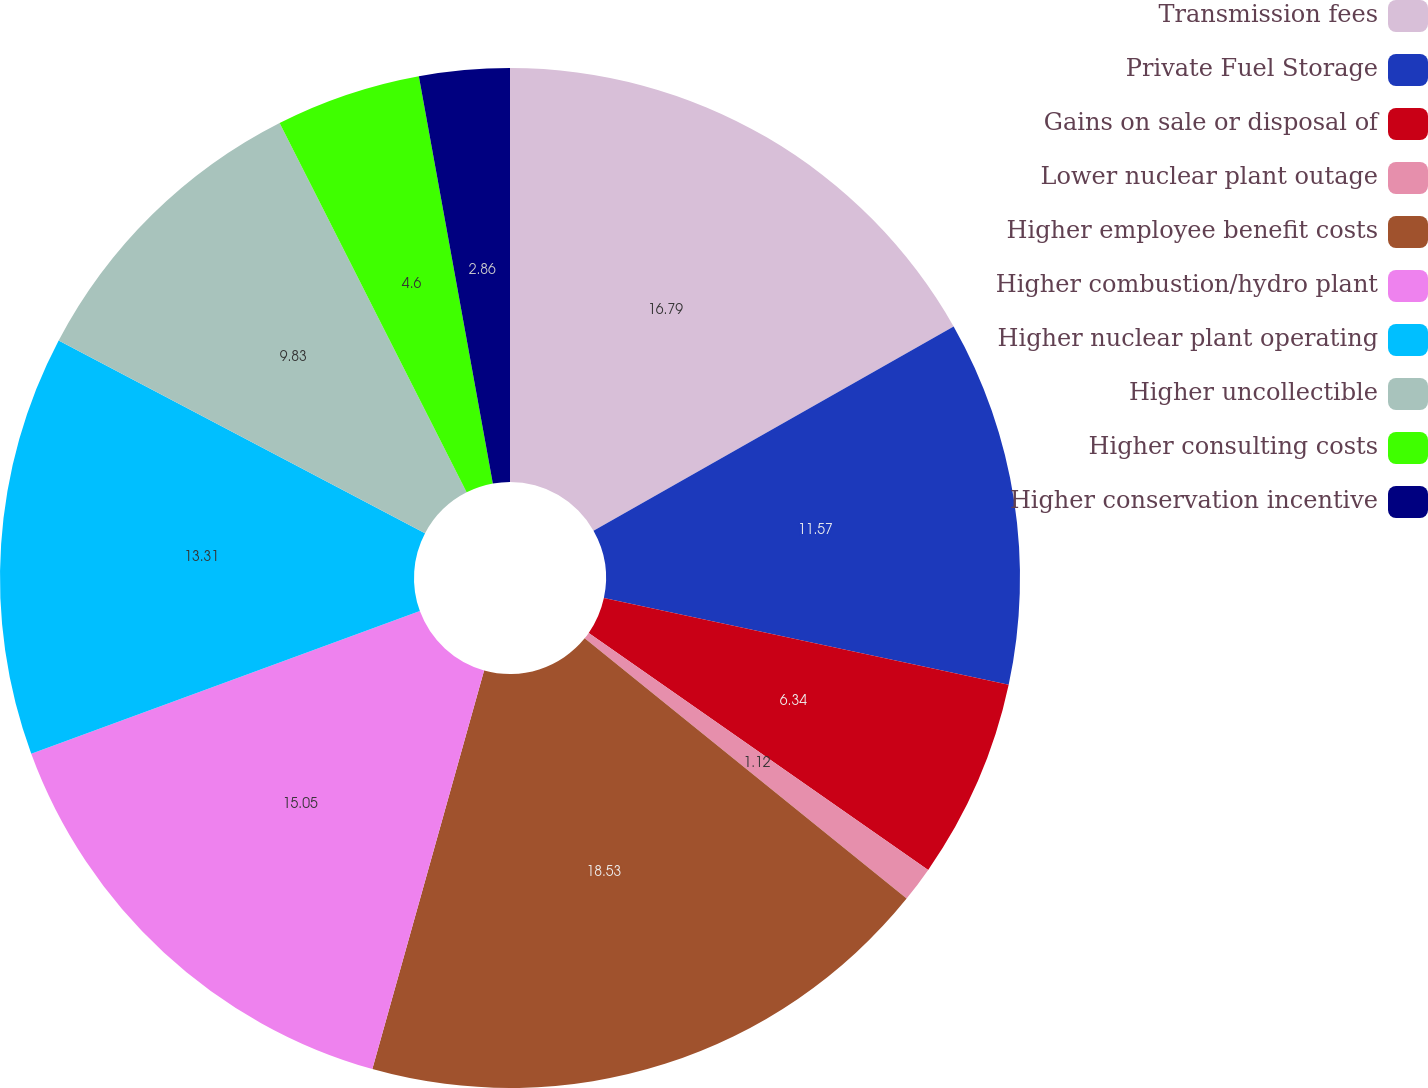Convert chart. <chart><loc_0><loc_0><loc_500><loc_500><pie_chart><fcel>Transmission fees<fcel>Private Fuel Storage<fcel>Gains on sale or disposal of<fcel>Lower nuclear plant outage<fcel>Higher employee benefit costs<fcel>Higher combustion/hydro plant<fcel>Higher nuclear plant operating<fcel>Higher uncollectible<fcel>Higher consulting costs<fcel>Higher conservation incentive<nl><fcel>16.79%<fcel>11.57%<fcel>6.34%<fcel>1.12%<fcel>18.53%<fcel>15.05%<fcel>13.31%<fcel>9.83%<fcel>4.6%<fcel>2.86%<nl></chart> 